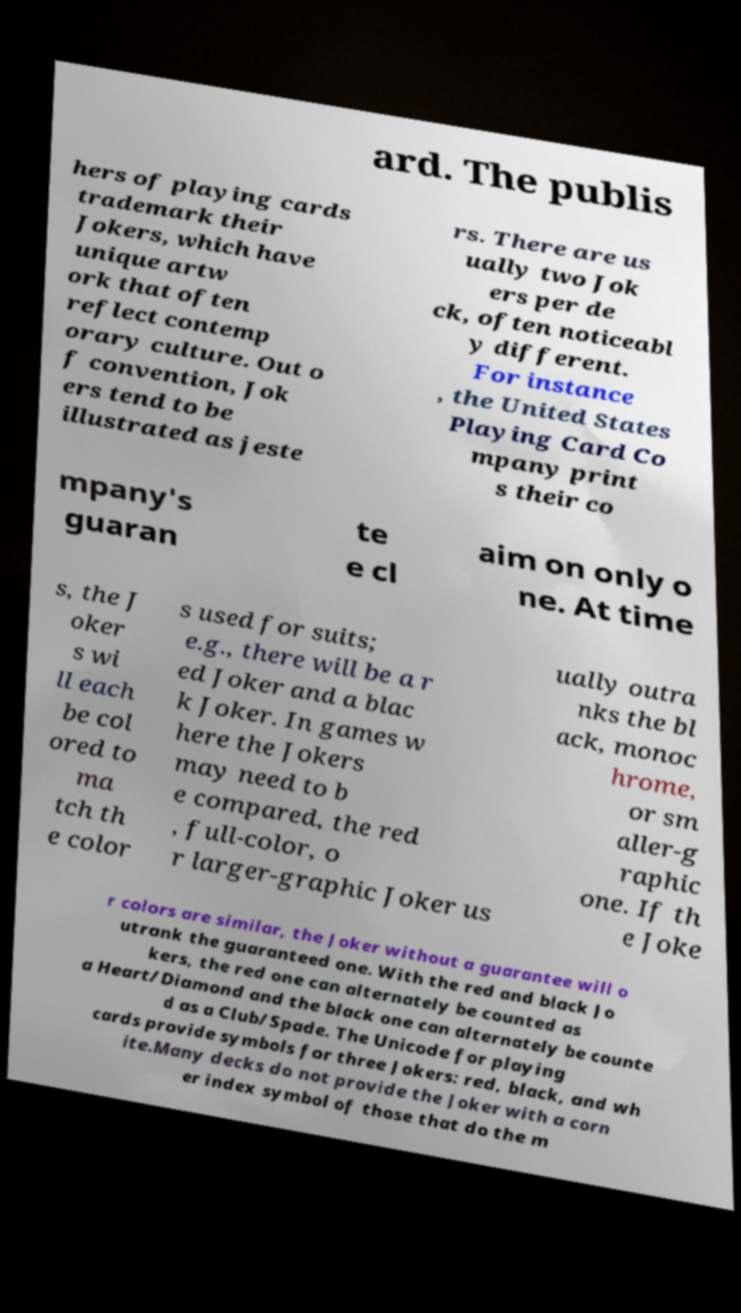Could you assist in decoding the text presented in this image and type it out clearly? ard. The publis hers of playing cards trademark their Jokers, which have unique artw ork that often reflect contemp orary culture. Out o f convention, Jok ers tend to be illustrated as jeste rs. There are us ually two Jok ers per de ck, often noticeabl y different. For instance , the United States Playing Card Co mpany print s their co mpany's guaran te e cl aim on only o ne. At time s, the J oker s wi ll each be col ored to ma tch th e color s used for suits; e.g., there will be a r ed Joker and a blac k Joker. In games w here the Jokers may need to b e compared, the red , full-color, o r larger-graphic Joker us ually outra nks the bl ack, monoc hrome, or sm aller-g raphic one. If th e Joke r colors are similar, the Joker without a guarantee will o utrank the guaranteed one. With the red and black Jo kers, the red one can alternately be counted as a Heart/Diamond and the black one can alternately be counte d as a Club/Spade. The Unicode for playing cards provide symbols for three Jokers: red, black, and wh ite.Many decks do not provide the Joker with a corn er index symbol of those that do the m 